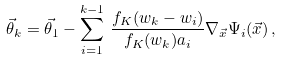Convert formula to latex. <formula><loc_0><loc_0><loc_500><loc_500>\vec { \theta } _ { k } = \vec { \theta } _ { 1 } - \sum _ { i = 1 } ^ { k - 1 } \, \frac { f _ { K } ( w _ { k } - w _ { i } ) } { f _ { K } ( w _ { k } ) a _ { i } } \nabla _ { \vec { x } } \Psi _ { i } ( \vec { x } ) \, ,</formula> 